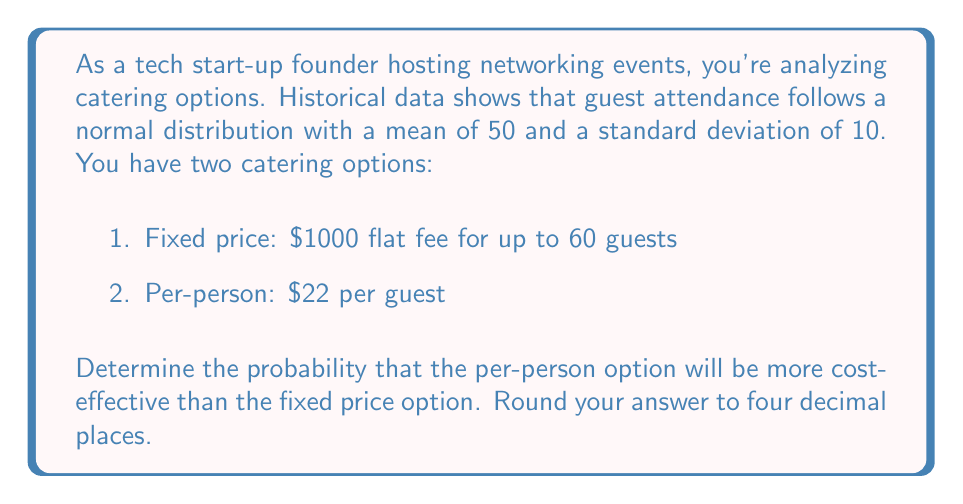What is the answer to this math problem? Let's approach this step-by-step:

1) The per-person option is more cost-effective when the number of guests (x) multiplied by $22 is less than $1000.

   $$22x < 1000$$
   $$x < \frac{1000}{22} \approx 45.45$$

2) We need to find the probability that x < 45.45 given that x follows a normal distribution with mean μ = 50 and standard deviation σ = 10.

3) To do this, we need to calculate the z-score:

   $$z = \frac{x - \mu}{\sigma} = \frac{45.45 - 50}{10} = -0.455$$

4) Now we need to find the probability that Z < -0.455 using a standard normal distribution table or calculator.

5) Using a standard normal distribution calculator, we find:

   P(Z < -0.455) ≈ 0.3246

Therefore, the probability that the per-person option will be more cost-effective is approximately 0.3246 or 32.46%.
Answer: 0.3246 